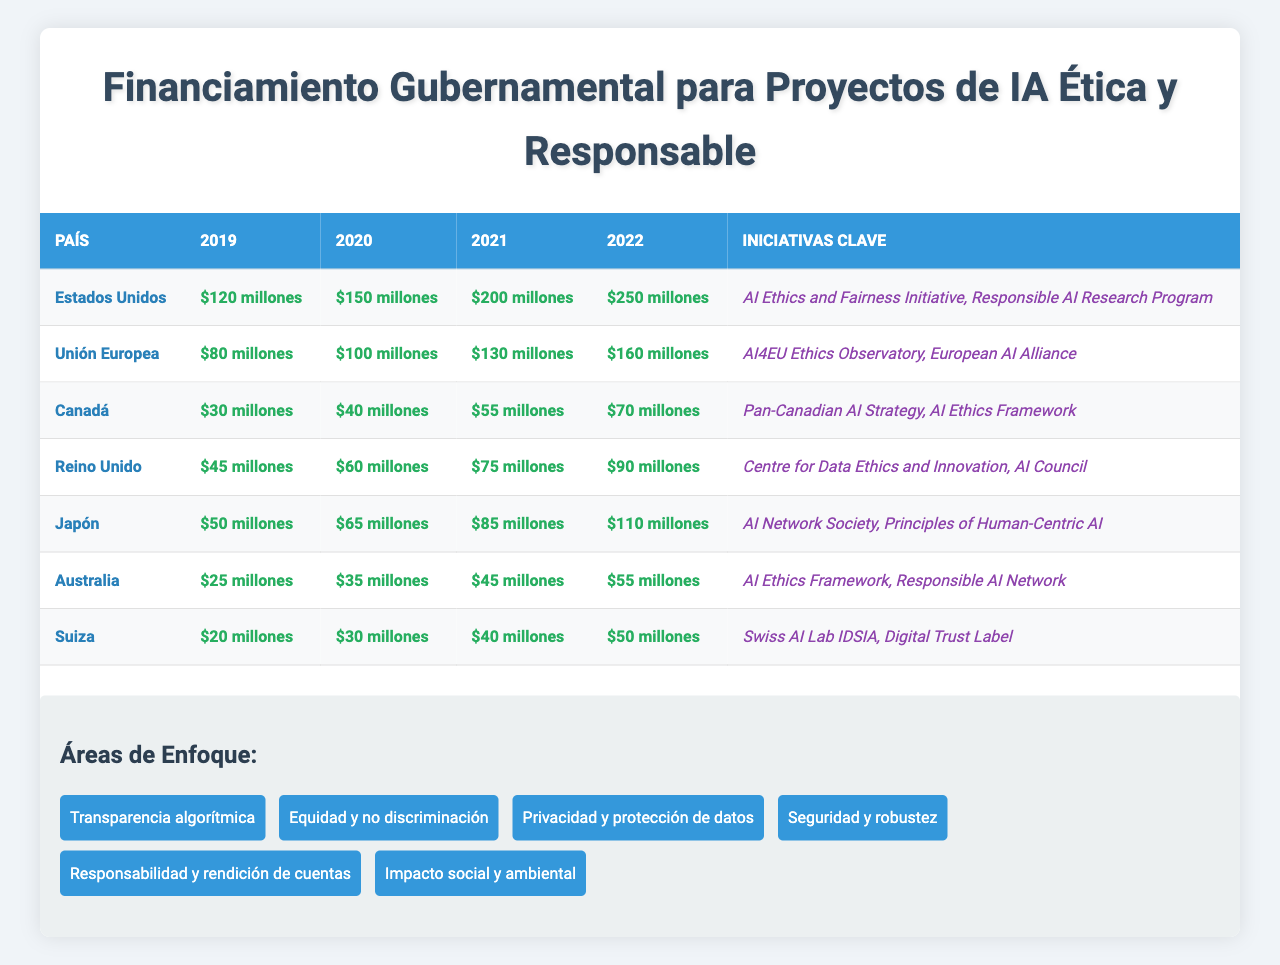¿Cuánto financiamiento recibió Canadá en 2022? En la tabla, se puede ver que el financiamiento para Canadá en 2022 es de $70 millones.
Answer: $70 millones ¿Cuál país tuvo el mayor incremento de financiamiento entre 2019 y 2022? Al observar la tabla, se ve que Estados Unidos tuvo un financiamiento de $120 millones en 2019 y de $250 millones en 2022, lo que representa un incremento de $130 millones. Este es el incremento más grande comparado con otros países.
Answer: Estados Unidos ¿Es verdad que Japón aumentó su financiamiento anualmente entre 2019 y 2022? En la tabla, los datos de financiamiento para Japón son $50 millones en 2019, $65 millones en 2020, $85 millones en 2021 y $110 millones en 2022. Dado que cada año el financiamiento es mayor que el anterior, esto confirma que Japón aumentó su financiamiento anualmente.
Answer: Sí ¿Cuál es el promedio de financiamiento para la Unión Europea durante los años disponibles? La suma del financiamiento para la Unión Europea en los años 2019, 2020, 2021 y 2022 es $80 + $100 + $130 + $160 = $470 millones. Luego, dividiendo $470 entre 4 años, se obtiene un promedio de $117.5 millones.
Answer: $117.5 millones ¿Cuánto financiamiento total recibieron Australia y Suiza entre 2019 y 2022? Al sumar el financiamiento de Australia ($25 + $35 + $45 + $55) que da $160 millones y de Suiza ($20 + $30 + $40 + $50) que da $140 millones, se obtiene un total combinado de $160 + $140 = $300 millones.
Answer: $300 millones ¿Qué áreas de enfoque son mencionadas en la tabla? En la sección de áreas de enfoque, las mencionadas son: Transparencia algorítmica, Equidad y no discriminación, Privacidad y protección de datos, Seguridad y robustez, Responsabilidad y rendición de cuentas, Impacto social y ambiental.
Answer: Seis áreas de enfoque ¿Cuál país tiene el financiamiento más bajo en 2021? Observando la tabla, se puede ver que en 2021, Canadá tiene el financiamiento más bajo con $55 millones.
Answer: Canadá ¿Qué dos iniciativas clave se mencionan para Reino Unido? En la tabla, las iniciativas clave para Reino Unido son "Centre for Data Ethics and Innovation" y "AI Council".
Answer: Dos iniciativas clave ¿Cuál es la diferencia en financiamiento entre el país que más financiamiento recibió y el que menos recibió en 2022? Estados Unidos recibió $250 millones y Australia recibió $55 millones en 2022. La diferencia es $250 - $55 = $195 millones.
Answer: $195 millones ¿Cuál fue el financiamiento total en 2020 para todos los países combinados? Sumando los financiamientos de 2020 de todos los países: $150 (EE.UU.) + $100 (UE) + $40 (Canadá) + $60 (Reino Unido) + $65 (Japón) + $35 (Australia) + $30 (Suiza) = $480 millones.
Answer: $480 millones 